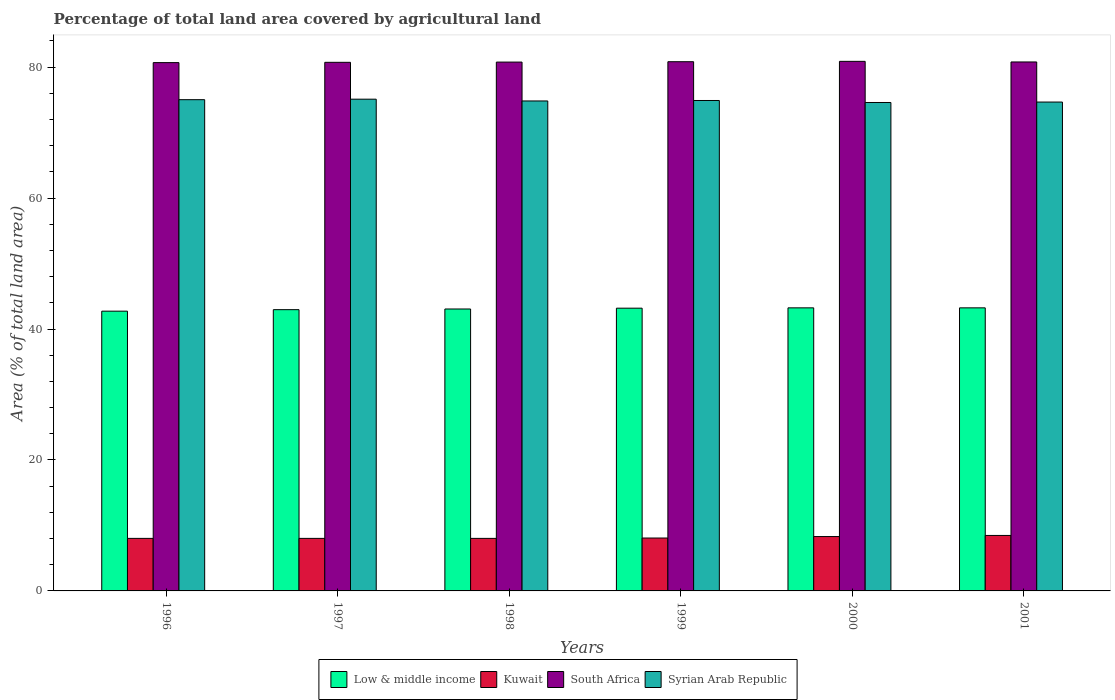How many different coloured bars are there?
Your answer should be very brief. 4. Are the number of bars on each tick of the X-axis equal?
Provide a short and direct response. Yes. How many bars are there on the 4th tick from the right?
Your answer should be very brief. 4. What is the label of the 6th group of bars from the left?
Your answer should be compact. 2001. In how many cases, is the number of bars for a given year not equal to the number of legend labels?
Ensure brevity in your answer.  0. What is the percentage of agricultural land in Syrian Arab Republic in 1997?
Make the answer very short. 75.11. Across all years, what is the maximum percentage of agricultural land in Low & middle income?
Give a very brief answer. 43.24. Across all years, what is the minimum percentage of agricultural land in South Africa?
Your response must be concise. 80.69. In which year was the percentage of agricultural land in Low & middle income minimum?
Your response must be concise. 1996. What is the total percentage of agricultural land in Syrian Arab Republic in the graph?
Offer a terse response. 449.17. What is the difference between the percentage of agricultural land in South Africa in 1996 and that in 1999?
Your answer should be very brief. -0.14. What is the difference between the percentage of agricultural land in South Africa in 1998 and the percentage of agricultural land in Low & middle income in 1997?
Ensure brevity in your answer.  37.81. What is the average percentage of agricultural land in Syrian Arab Republic per year?
Make the answer very short. 74.86. In the year 2000, what is the difference between the percentage of agricultural land in Kuwait and percentage of agricultural land in Syrian Arab Republic?
Keep it short and to the point. -66.3. What is the ratio of the percentage of agricultural land in South Africa in 1997 to that in 1999?
Your response must be concise. 1. Is the percentage of agricultural land in Syrian Arab Republic in 1997 less than that in 2001?
Your answer should be very brief. No. Is the difference between the percentage of agricultural land in Kuwait in 1999 and 2001 greater than the difference between the percentage of agricultural land in Syrian Arab Republic in 1999 and 2001?
Ensure brevity in your answer.  No. What is the difference between the highest and the second highest percentage of agricultural land in Syrian Arab Republic?
Keep it short and to the point. 0.08. What is the difference between the highest and the lowest percentage of agricultural land in Kuwait?
Give a very brief answer. 0.45. In how many years, is the percentage of agricultural land in South Africa greater than the average percentage of agricultural land in South Africa taken over all years?
Give a very brief answer. 3. Is the sum of the percentage of agricultural land in South Africa in 1998 and 2001 greater than the maximum percentage of agricultural land in Kuwait across all years?
Offer a very short reply. Yes. Is it the case that in every year, the sum of the percentage of agricultural land in Low & middle income and percentage of agricultural land in Syrian Arab Republic is greater than the sum of percentage of agricultural land in Kuwait and percentage of agricultural land in South Africa?
Provide a succinct answer. No. What does the 1st bar from the left in 1997 represents?
Your response must be concise. Low & middle income. What does the 3rd bar from the right in 1999 represents?
Your answer should be compact. Kuwait. Is it the case that in every year, the sum of the percentage of agricultural land in Kuwait and percentage of agricultural land in Syrian Arab Republic is greater than the percentage of agricultural land in South Africa?
Provide a succinct answer. Yes. Are all the bars in the graph horizontal?
Give a very brief answer. No. How many years are there in the graph?
Ensure brevity in your answer.  6. What is the difference between two consecutive major ticks on the Y-axis?
Provide a succinct answer. 20. Are the values on the major ticks of Y-axis written in scientific E-notation?
Offer a very short reply. No. Does the graph contain any zero values?
Provide a short and direct response. No. Does the graph contain grids?
Provide a succinct answer. No. Where does the legend appear in the graph?
Offer a terse response. Bottom center. What is the title of the graph?
Make the answer very short. Percentage of total land area covered by agricultural land. Does "Haiti" appear as one of the legend labels in the graph?
Make the answer very short. No. What is the label or title of the Y-axis?
Make the answer very short. Area (% of total land area). What is the Area (% of total land area) of Low & middle income in 1996?
Ensure brevity in your answer.  42.73. What is the Area (% of total land area) of Kuwait in 1996?
Ensure brevity in your answer.  8.02. What is the Area (% of total land area) of South Africa in 1996?
Provide a succinct answer. 80.69. What is the Area (% of total land area) of Syrian Arab Republic in 1996?
Keep it short and to the point. 75.04. What is the Area (% of total land area) in Low & middle income in 1997?
Your response must be concise. 42.96. What is the Area (% of total land area) in Kuwait in 1997?
Your answer should be very brief. 8.02. What is the Area (% of total land area) of South Africa in 1997?
Offer a very short reply. 80.74. What is the Area (% of total land area) in Syrian Arab Republic in 1997?
Your answer should be very brief. 75.11. What is the Area (% of total land area) in Low & middle income in 1998?
Your answer should be very brief. 43.06. What is the Area (% of total land area) of Kuwait in 1998?
Offer a very short reply. 8.02. What is the Area (% of total land area) in South Africa in 1998?
Ensure brevity in your answer.  80.78. What is the Area (% of total land area) of Syrian Arab Republic in 1998?
Provide a succinct answer. 74.84. What is the Area (% of total land area) of Low & middle income in 1999?
Keep it short and to the point. 43.19. What is the Area (% of total land area) of Kuwait in 1999?
Your answer should be very brief. 8.08. What is the Area (% of total land area) in South Africa in 1999?
Provide a short and direct response. 80.83. What is the Area (% of total land area) in Syrian Arab Republic in 1999?
Your response must be concise. 74.91. What is the Area (% of total land area) in Low & middle income in 2000?
Your answer should be very brief. 43.24. What is the Area (% of total land area) in Kuwait in 2000?
Your answer should be compact. 8.31. What is the Area (% of total land area) in South Africa in 2000?
Give a very brief answer. 80.89. What is the Area (% of total land area) of Syrian Arab Republic in 2000?
Provide a short and direct response. 74.61. What is the Area (% of total land area) of Low & middle income in 2001?
Provide a short and direct response. 43.24. What is the Area (% of total land area) of Kuwait in 2001?
Offer a terse response. 8.47. What is the Area (% of total land area) in South Africa in 2001?
Keep it short and to the point. 80.8. What is the Area (% of total land area) of Syrian Arab Republic in 2001?
Make the answer very short. 74.67. Across all years, what is the maximum Area (% of total land area) in Low & middle income?
Offer a terse response. 43.24. Across all years, what is the maximum Area (% of total land area) of Kuwait?
Provide a short and direct response. 8.47. Across all years, what is the maximum Area (% of total land area) of South Africa?
Give a very brief answer. 80.89. Across all years, what is the maximum Area (% of total land area) of Syrian Arab Republic?
Offer a very short reply. 75.11. Across all years, what is the minimum Area (% of total land area) in Low & middle income?
Offer a terse response. 42.73. Across all years, what is the minimum Area (% of total land area) in Kuwait?
Make the answer very short. 8.02. Across all years, what is the minimum Area (% of total land area) of South Africa?
Make the answer very short. 80.69. Across all years, what is the minimum Area (% of total land area) in Syrian Arab Republic?
Your response must be concise. 74.61. What is the total Area (% of total land area) in Low & middle income in the graph?
Your response must be concise. 258.42. What is the total Area (% of total land area) of Kuwait in the graph?
Offer a terse response. 48.93. What is the total Area (% of total land area) in South Africa in the graph?
Provide a short and direct response. 484.73. What is the total Area (% of total land area) in Syrian Arab Republic in the graph?
Your answer should be compact. 449.17. What is the difference between the Area (% of total land area) of Low & middle income in 1996 and that in 1997?
Ensure brevity in your answer.  -0.23. What is the difference between the Area (% of total land area) of South Africa in 1996 and that in 1997?
Offer a terse response. -0.05. What is the difference between the Area (% of total land area) of Syrian Arab Republic in 1996 and that in 1997?
Ensure brevity in your answer.  -0.08. What is the difference between the Area (% of total land area) in Low & middle income in 1996 and that in 1998?
Offer a very short reply. -0.33. What is the difference between the Area (% of total land area) of South Africa in 1996 and that in 1998?
Provide a succinct answer. -0.08. What is the difference between the Area (% of total land area) of Syrian Arab Republic in 1996 and that in 1998?
Your answer should be very brief. 0.2. What is the difference between the Area (% of total land area) of Low & middle income in 1996 and that in 1999?
Your answer should be very brief. -0.45. What is the difference between the Area (% of total land area) in Kuwait in 1996 and that in 1999?
Give a very brief answer. -0.06. What is the difference between the Area (% of total land area) in South Africa in 1996 and that in 1999?
Keep it short and to the point. -0.14. What is the difference between the Area (% of total land area) in Syrian Arab Republic in 1996 and that in 1999?
Your answer should be compact. 0.13. What is the difference between the Area (% of total land area) of Low & middle income in 1996 and that in 2000?
Make the answer very short. -0.51. What is the difference between the Area (% of total land area) in Kuwait in 1996 and that in 2000?
Provide a short and direct response. -0.28. What is the difference between the Area (% of total land area) in South Africa in 1996 and that in 2000?
Offer a very short reply. -0.19. What is the difference between the Area (% of total land area) in Syrian Arab Republic in 1996 and that in 2000?
Provide a succinct answer. 0.43. What is the difference between the Area (% of total land area) of Low & middle income in 1996 and that in 2001?
Make the answer very short. -0.51. What is the difference between the Area (% of total land area) of Kuwait in 1996 and that in 2001?
Give a very brief answer. -0.45. What is the difference between the Area (% of total land area) of South Africa in 1996 and that in 2001?
Make the answer very short. -0.1. What is the difference between the Area (% of total land area) of Syrian Arab Republic in 1996 and that in 2001?
Provide a succinct answer. 0.36. What is the difference between the Area (% of total land area) in Low & middle income in 1997 and that in 1998?
Give a very brief answer. -0.1. What is the difference between the Area (% of total land area) of South Africa in 1997 and that in 1998?
Ensure brevity in your answer.  -0.04. What is the difference between the Area (% of total land area) of Syrian Arab Republic in 1997 and that in 1998?
Your answer should be very brief. 0.27. What is the difference between the Area (% of total land area) in Low & middle income in 1997 and that in 1999?
Your answer should be very brief. -0.22. What is the difference between the Area (% of total land area) of Kuwait in 1997 and that in 1999?
Your response must be concise. -0.06. What is the difference between the Area (% of total land area) in South Africa in 1997 and that in 1999?
Provide a short and direct response. -0.09. What is the difference between the Area (% of total land area) in Syrian Arab Republic in 1997 and that in 1999?
Provide a succinct answer. 0.2. What is the difference between the Area (% of total land area) of Low & middle income in 1997 and that in 2000?
Offer a very short reply. -0.28. What is the difference between the Area (% of total land area) of Kuwait in 1997 and that in 2000?
Provide a succinct answer. -0.28. What is the difference between the Area (% of total land area) in South Africa in 1997 and that in 2000?
Your answer should be compact. -0.15. What is the difference between the Area (% of total land area) of Syrian Arab Republic in 1997 and that in 2000?
Your answer should be very brief. 0.51. What is the difference between the Area (% of total land area) of Low & middle income in 1997 and that in 2001?
Give a very brief answer. -0.28. What is the difference between the Area (% of total land area) of Kuwait in 1997 and that in 2001?
Make the answer very short. -0.45. What is the difference between the Area (% of total land area) of South Africa in 1997 and that in 2001?
Keep it short and to the point. -0.06. What is the difference between the Area (% of total land area) in Syrian Arab Republic in 1997 and that in 2001?
Your response must be concise. 0.44. What is the difference between the Area (% of total land area) of Low & middle income in 1998 and that in 1999?
Your answer should be compact. -0.12. What is the difference between the Area (% of total land area) of Kuwait in 1998 and that in 1999?
Make the answer very short. -0.06. What is the difference between the Area (% of total land area) of South Africa in 1998 and that in 1999?
Your response must be concise. -0.06. What is the difference between the Area (% of total land area) in Syrian Arab Republic in 1998 and that in 1999?
Make the answer very short. -0.07. What is the difference between the Area (% of total land area) of Low & middle income in 1998 and that in 2000?
Provide a succinct answer. -0.18. What is the difference between the Area (% of total land area) of Kuwait in 1998 and that in 2000?
Your answer should be compact. -0.28. What is the difference between the Area (% of total land area) of South Africa in 1998 and that in 2000?
Give a very brief answer. -0.11. What is the difference between the Area (% of total land area) in Syrian Arab Republic in 1998 and that in 2000?
Keep it short and to the point. 0.23. What is the difference between the Area (% of total land area) of Low & middle income in 1998 and that in 2001?
Your answer should be compact. -0.17. What is the difference between the Area (% of total land area) of Kuwait in 1998 and that in 2001?
Make the answer very short. -0.45. What is the difference between the Area (% of total land area) of South Africa in 1998 and that in 2001?
Keep it short and to the point. -0.02. What is the difference between the Area (% of total land area) of Syrian Arab Republic in 1998 and that in 2001?
Offer a very short reply. 0.17. What is the difference between the Area (% of total land area) in Low & middle income in 1999 and that in 2000?
Give a very brief answer. -0.05. What is the difference between the Area (% of total land area) of Kuwait in 1999 and that in 2000?
Make the answer very short. -0.22. What is the difference between the Area (% of total land area) of South Africa in 1999 and that in 2000?
Your answer should be very brief. -0.06. What is the difference between the Area (% of total land area) of Syrian Arab Republic in 1999 and that in 2000?
Ensure brevity in your answer.  0.3. What is the difference between the Area (% of total land area) of Low & middle income in 1999 and that in 2001?
Your response must be concise. -0.05. What is the difference between the Area (% of total land area) of Kuwait in 1999 and that in 2001?
Offer a very short reply. -0.39. What is the difference between the Area (% of total land area) of South Africa in 1999 and that in 2001?
Offer a terse response. 0.04. What is the difference between the Area (% of total land area) in Syrian Arab Republic in 1999 and that in 2001?
Your answer should be very brief. 0.24. What is the difference between the Area (% of total land area) of Low & middle income in 2000 and that in 2001?
Make the answer very short. 0. What is the difference between the Area (% of total land area) of Kuwait in 2000 and that in 2001?
Offer a very short reply. -0.17. What is the difference between the Area (% of total land area) in South Africa in 2000 and that in 2001?
Offer a terse response. 0.09. What is the difference between the Area (% of total land area) of Syrian Arab Republic in 2000 and that in 2001?
Offer a very short reply. -0.07. What is the difference between the Area (% of total land area) of Low & middle income in 1996 and the Area (% of total land area) of Kuwait in 1997?
Your response must be concise. 34.71. What is the difference between the Area (% of total land area) of Low & middle income in 1996 and the Area (% of total land area) of South Africa in 1997?
Provide a short and direct response. -38.01. What is the difference between the Area (% of total land area) in Low & middle income in 1996 and the Area (% of total land area) in Syrian Arab Republic in 1997?
Your response must be concise. -32.38. What is the difference between the Area (% of total land area) in Kuwait in 1996 and the Area (% of total land area) in South Africa in 1997?
Make the answer very short. -72.72. What is the difference between the Area (% of total land area) of Kuwait in 1996 and the Area (% of total land area) of Syrian Arab Republic in 1997?
Your answer should be compact. -67.09. What is the difference between the Area (% of total land area) of South Africa in 1996 and the Area (% of total land area) of Syrian Arab Republic in 1997?
Provide a succinct answer. 5.58. What is the difference between the Area (% of total land area) in Low & middle income in 1996 and the Area (% of total land area) in Kuwait in 1998?
Your response must be concise. 34.71. What is the difference between the Area (% of total land area) of Low & middle income in 1996 and the Area (% of total land area) of South Africa in 1998?
Your response must be concise. -38.04. What is the difference between the Area (% of total land area) in Low & middle income in 1996 and the Area (% of total land area) in Syrian Arab Republic in 1998?
Keep it short and to the point. -32.11. What is the difference between the Area (% of total land area) in Kuwait in 1996 and the Area (% of total land area) in South Africa in 1998?
Your answer should be very brief. -72.75. What is the difference between the Area (% of total land area) of Kuwait in 1996 and the Area (% of total land area) of Syrian Arab Republic in 1998?
Your answer should be compact. -66.81. What is the difference between the Area (% of total land area) in South Africa in 1996 and the Area (% of total land area) in Syrian Arab Republic in 1998?
Offer a very short reply. 5.86. What is the difference between the Area (% of total land area) in Low & middle income in 1996 and the Area (% of total land area) in Kuwait in 1999?
Provide a succinct answer. 34.65. What is the difference between the Area (% of total land area) in Low & middle income in 1996 and the Area (% of total land area) in South Africa in 1999?
Your answer should be very brief. -38.1. What is the difference between the Area (% of total land area) in Low & middle income in 1996 and the Area (% of total land area) in Syrian Arab Republic in 1999?
Provide a succinct answer. -32.18. What is the difference between the Area (% of total land area) in Kuwait in 1996 and the Area (% of total land area) in South Africa in 1999?
Provide a succinct answer. -72.81. What is the difference between the Area (% of total land area) in Kuwait in 1996 and the Area (% of total land area) in Syrian Arab Republic in 1999?
Your answer should be very brief. -66.89. What is the difference between the Area (% of total land area) in South Africa in 1996 and the Area (% of total land area) in Syrian Arab Republic in 1999?
Provide a short and direct response. 5.78. What is the difference between the Area (% of total land area) in Low & middle income in 1996 and the Area (% of total land area) in Kuwait in 2000?
Your response must be concise. 34.43. What is the difference between the Area (% of total land area) of Low & middle income in 1996 and the Area (% of total land area) of South Africa in 2000?
Offer a very short reply. -38.16. What is the difference between the Area (% of total land area) of Low & middle income in 1996 and the Area (% of total land area) of Syrian Arab Republic in 2000?
Make the answer very short. -31.87. What is the difference between the Area (% of total land area) of Kuwait in 1996 and the Area (% of total land area) of South Africa in 2000?
Make the answer very short. -72.86. What is the difference between the Area (% of total land area) of Kuwait in 1996 and the Area (% of total land area) of Syrian Arab Republic in 2000?
Offer a terse response. -66.58. What is the difference between the Area (% of total land area) in South Africa in 1996 and the Area (% of total land area) in Syrian Arab Republic in 2000?
Provide a short and direct response. 6.09. What is the difference between the Area (% of total land area) in Low & middle income in 1996 and the Area (% of total land area) in Kuwait in 2001?
Offer a very short reply. 34.26. What is the difference between the Area (% of total land area) in Low & middle income in 1996 and the Area (% of total land area) in South Africa in 2001?
Make the answer very short. -38.06. What is the difference between the Area (% of total land area) of Low & middle income in 1996 and the Area (% of total land area) of Syrian Arab Republic in 2001?
Provide a short and direct response. -31.94. What is the difference between the Area (% of total land area) of Kuwait in 1996 and the Area (% of total land area) of South Africa in 2001?
Give a very brief answer. -72.77. What is the difference between the Area (% of total land area) of Kuwait in 1996 and the Area (% of total land area) of Syrian Arab Republic in 2001?
Offer a very short reply. -66.65. What is the difference between the Area (% of total land area) of South Africa in 1996 and the Area (% of total land area) of Syrian Arab Republic in 2001?
Provide a succinct answer. 6.02. What is the difference between the Area (% of total land area) in Low & middle income in 1997 and the Area (% of total land area) in Kuwait in 1998?
Keep it short and to the point. 34.94. What is the difference between the Area (% of total land area) in Low & middle income in 1997 and the Area (% of total land area) in South Africa in 1998?
Ensure brevity in your answer.  -37.81. What is the difference between the Area (% of total land area) in Low & middle income in 1997 and the Area (% of total land area) in Syrian Arab Republic in 1998?
Provide a short and direct response. -31.88. What is the difference between the Area (% of total land area) in Kuwait in 1997 and the Area (% of total land area) in South Africa in 1998?
Provide a short and direct response. -72.75. What is the difference between the Area (% of total land area) of Kuwait in 1997 and the Area (% of total land area) of Syrian Arab Republic in 1998?
Provide a succinct answer. -66.81. What is the difference between the Area (% of total land area) of South Africa in 1997 and the Area (% of total land area) of Syrian Arab Republic in 1998?
Provide a short and direct response. 5.9. What is the difference between the Area (% of total land area) of Low & middle income in 1997 and the Area (% of total land area) of Kuwait in 1999?
Ensure brevity in your answer.  34.88. What is the difference between the Area (% of total land area) in Low & middle income in 1997 and the Area (% of total land area) in South Africa in 1999?
Your answer should be very brief. -37.87. What is the difference between the Area (% of total land area) in Low & middle income in 1997 and the Area (% of total land area) in Syrian Arab Republic in 1999?
Your answer should be compact. -31.95. What is the difference between the Area (% of total land area) of Kuwait in 1997 and the Area (% of total land area) of South Africa in 1999?
Make the answer very short. -72.81. What is the difference between the Area (% of total land area) of Kuwait in 1997 and the Area (% of total land area) of Syrian Arab Republic in 1999?
Your response must be concise. -66.89. What is the difference between the Area (% of total land area) of South Africa in 1997 and the Area (% of total land area) of Syrian Arab Republic in 1999?
Keep it short and to the point. 5.83. What is the difference between the Area (% of total land area) in Low & middle income in 1997 and the Area (% of total land area) in Kuwait in 2000?
Your response must be concise. 34.66. What is the difference between the Area (% of total land area) in Low & middle income in 1997 and the Area (% of total land area) in South Africa in 2000?
Give a very brief answer. -37.93. What is the difference between the Area (% of total land area) of Low & middle income in 1997 and the Area (% of total land area) of Syrian Arab Republic in 2000?
Offer a very short reply. -31.64. What is the difference between the Area (% of total land area) of Kuwait in 1997 and the Area (% of total land area) of South Africa in 2000?
Offer a terse response. -72.86. What is the difference between the Area (% of total land area) in Kuwait in 1997 and the Area (% of total land area) in Syrian Arab Republic in 2000?
Your answer should be very brief. -66.58. What is the difference between the Area (% of total land area) in South Africa in 1997 and the Area (% of total land area) in Syrian Arab Republic in 2000?
Keep it short and to the point. 6.13. What is the difference between the Area (% of total land area) in Low & middle income in 1997 and the Area (% of total land area) in Kuwait in 2001?
Give a very brief answer. 34.49. What is the difference between the Area (% of total land area) in Low & middle income in 1997 and the Area (% of total land area) in South Africa in 2001?
Offer a terse response. -37.83. What is the difference between the Area (% of total land area) of Low & middle income in 1997 and the Area (% of total land area) of Syrian Arab Republic in 2001?
Provide a succinct answer. -31.71. What is the difference between the Area (% of total land area) of Kuwait in 1997 and the Area (% of total land area) of South Africa in 2001?
Your answer should be compact. -72.77. What is the difference between the Area (% of total land area) in Kuwait in 1997 and the Area (% of total land area) in Syrian Arab Republic in 2001?
Your answer should be very brief. -66.65. What is the difference between the Area (% of total land area) in South Africa in 1997 and the Area (% of total land area) in Syrian Arab Republic in 2001?
Your response must be concise. 6.07. What is the difference between the Area (% of total land area) of Low & middle income in 1998 and the Area (% of total land area) of Kuwait in 1999?
Your answer should be compact. 34.98. What is the difference between the Area (% of total land area) in Low & middle income in 1998 and the Area (% of total land area) in South Africa in 1999?
Provide a short and direct response. -37.77. What is the difference between the Area (% of total land area) of Low & middle income in 1998 and the Area (% of total land area) of Syrian Arab Republic in 1999?
Your answer should be compact. -31.85. What is the difference between the Area (% of total land area) in Kuwait in 1998 and the Area (% of total land area) in South Africa in 1999?
Make the answer very short. -72.81. What is the difference between the Area (% of total land area) in Kuwait in 1998 and the Area (% of total land area) in Syrian Arab Republic in 1999?
Your response must be concise. -66.89. What is the difference between the Area (% of total land area) of South Africa in 1998 and the Area (% of total land area) of Syrian Arab Republic in 1999?
Keep it short and to the point. 5.87. What is the difference between the Area (% of total land area) of Low & middle income in 1998 and the Area (% of total land area) of Kuwait in 2000?
Your answer should be compact. 34.76. What is the difference between the Area (% of total land area) in Low & middle income in 1998 and the Area (% of total land area) in South Africa in 2000?
Your answer should be compact. -37.83. What is the difference between the Area (% of total land area) in Low & middle income in 1998 and the Area (% of total land area) in Syrian Arab Republic in 2000?
Ensure brevity in your answer.  -31.54. What is the difference between the Area (% of total land area) in Kuwait in 1998 and the Area (% of total land area) in South Africa in 2000?
Ensure brevity in your answer.  -72.86. What is the difference between the Area (% of total land area) in Kuwait in 1998 and the Area (% of total land area) in Syrian Arab Republic in 2000?
Offer a terse response. -66.58. What is the difference between the Area (% of total land area) in South Africa in 1998 and the Area (% of total land area) in Syrian Arab Republic in 2000?
Provide a succinct answer. 6.17. What is the difference between the Area (% of total land area) in Low & middle income in 1998 and the Area (% of total land area) in Kuwait in 2001?
Provide a succinct answer. 34.59. What is the difference between the Area (% of total land area) in Low & middle income in 1998 and the Area (% of total land area) in South Africa in 2001?
Give a very brief answer. -37.73. What is the difference between the Area (% of total land area) of Low & middle income in 1998 and the Area (% of total land area) of Syrian Arab Republic in 2001?
Offer a very short reply. -31.61. What is the difference between the Area (% of total land area) of Kuwait in 1998 and the Area (% of total land area) of South Africa in 2001?
Ensure brevity in your answer.  -72.77. What is the difference between the Area (% of total land area) of Kuwait in 1998 and the Area (% of total land area) of Syrian Arab Republic in 2001?
Make the answer very short. -66.65. What is the difference between the Area (% of total land area) in South Africa in 1998 and the Area (% of total land area) in Syrian Arab Republic in 2001?
Your response must be concise. 6.1. What is the difference between the Area (% of total land area) in Low & middle income in 1999 and the Area (% of total land area) in Kuwait in 2000?
Offer a very short reply. 34.88. What is the difference between the Area (% of total land area) of Low & middle income in 1999 and the Area (% of total land area) of South Africa in 2000?
Make the answer very short. -37.7. What is the difference between the Area (% of total land area) of Low & middle income in 1999 and the Area (% of total land area) of Syrian Arab Republic in 2000?
Offer a very short reply. -31.42. What is the difference between the Area (% of total land area) in Kuwait in 1999 and the Area (% of total land area) in South Africa in 2000?
Provide a succinct answer. -72.81. What is the difference between the Area (% of total land area) in Kuwait in 1999 and the Area (% of total land area) in Syrian Arab Republic in 2000?
Your answer should be compact. -66.52. What is the difference between the Area (% of total land area) of South Africa in 1999 and the Area (% of total land area) of Syrian Arab Republic in 2000?
Ensure brevity in your answer.  6.23. What is the difference between the Area (% of total land area) of Low & middle income in 1999 and the Area (% of total land area) of Kuwait in 2001?
Make the answer very short. 34.71. What is the difference between the Area (% of total land area) of Low & middle income in 1999 and the Area (% of total land area) of South Africa in 2001?
Make the answer very short. -37.61. What is the difference between the Area (% of total land area) of Low & middle income in 1999 and the Area (% of total land area) of Syrian Arab Republic in 2001?
Your response must be concise. -31.48. What is the difference between the Area (% of total land area) in Kuwait in 1999 and the Area (% of total land area) in South Africa in 2001?
Your answer should be very brief. -72.72. What is the difference between the Area (% of total land area) in Kuwait in 1999 and the Area (% of total land area) in Syrian Arab Republic in 2001?
Your response must be concise. -66.59. What is the difference between the Area (% of total land area) in South Africa in 1999 and the Area (% of total land area) in Syrian Arab Republic in 2001?
Ensure brevity in your answer.  6.16. What is the difference between the Area (% of total land area) in Low & middle income in 2000 and the Area (% of total land area) in Kuwait in 2001?
Provide a short and direct response. 34.76. What is the difference between the Area (% of total land area) in Low & middle income in 2000 and the Area (% of total land area) in South Africa in 2001?
Your answer should be compact. -37.56. What is the difference between the Area (% of total land area) in Low & middle income in 2000 and the Area (% of total land area) in Syrian Arab Republic in 2001?
Your answer should be very brief. -31.43. What is the difference between the Area (% of total land area) of Kuwait in 2000 and the Area (% of total land area) of South Africa in 2001?
Your answer should be very brief. -72.49. What is the difference between the Area (% of total land area) of Kuwait in 2000 and the Area (% of total land area) of Syrian Arab Republic in 2001?
Your answer should be compact. -66.37. What is the difference between the Area (% of total land area) of South Africa in 2000 and the Area (% of total land area) of Syrian Arab Republic in 2001?
Your answer should be very brief. 6.22. What is the average Area (% of total land area) in Low & middle income per year?
Your answer should be compact. 43.07. What is the average Area (% of total land area) of Kuwait per year?
Your answer should be compact. 8.16. What is the average Area (% of total land area) of South Africa per year?
Your answer should be compact. 80.79. What is the average Area (% of total land area) in Syrian Arab Republic per year?
Offer a very short reply. 74.86. In the year 1996, what is the difference between the Area (% of total land area) of Low & middle income and Area (% of total land area) of Kuwait?
Make the answer very short. 34.71. In the year 1996, what is the difference between the Area (% of total land area) in Low & middle income and Area (% of total land area) in South Africa?
Provide a succinct answer. -37.96. In the year 1996, what is the difference between the Area (% of total land area) of Low & middle income and Area (% of total land area) of Syrian Arab Republic?
Ensure brevity in your answer.  -32.3. In the year 1996, what is the difference between the Area (% of total land area) in Kuwait and Area (% of total land area) in South Africa?
Make the answer very short. -72.67. In the year 1996, what is the difference between the Area (% of total land area) of Kuwait and Area (% of total land area) of Syrian Arab Republic?
Ensure brevity in your answer.  -67.01. In the year 1996, what is the difference between the Area (% of total land area) in South Africa and Area (% of total land area) in Syrian Arab Republic?
Give a very brief answer. 5.66. In the year 1997, what is the difference between the Area (% of total land area) of Low & middle income and Area (% of total land area) of Kuwait?
Your answer should be very brief. 34.94. In the year 1997, what is the difference between the Area (% of total land area) in Low & middle income and Area (% of total land area) in South Africa?
Make the answer very short. -37.78. In the year 1997, what is the difference between the Area (% of total land area) in Low & middle income and Area (% of total land area) in Syrian Arab Republic?
Make the answer very short. -32.15. In the year 1997, what is the difference between the Area (% of total land area) in Kuwait and Area (% of total land area) in South Africa?
Keep it short and to the point. -72.72. In the year 1997, what is the difference between the Area (% of total land area) of Kuwait and Area (% of total land area) of Syrian Arab Republic?
Your response must be concise. -67.09. In the year 1997, what is the difference between the Area (% of total land area) in South Africa and Area (% of total land area) in Syrian Arab Republic?
Your answer should be very brief. 5.63. In the year 1998, what is the difference between the Area (% of total land area) in Low & middle income and Area (% of total land area) in Kuwait?
Your answer should be very brief. 35.04. In the year 1998, what is the difference between the Area (% of total land area) of Low & middle income and Area (% of total land area) of South Africa?
Keep it short and to the point. -37.71. In the year 1998, what is the difference between the Area (% of total land area) in Low & middle income and Area (% of total land area) in Syrian Arab Republic?
Your response must be concise. -31.78. In the year 1998, what is the difference between the Area (% of total land area) of Kuwait and Area (% of total land area) of South Africa?
Give a very brief answer. -72.75. In the year 1998, what is the difference between the Area (% of total land area) of Kuwait and Area (% of total land area) of Syrian Arab Republic?
Keep it short and to the point. -66.81. In the year 1998, what is the difference between the Area (% of total land area) of South Africa and Area (% of total land area) of Syrian Arab Republic?
Keep it short and to the point. 5.94. In the year 1999, what is the difference between the Area (% of total land area) of Low & middle income and Area (% of total land area) of Kuwait?
Keep it short and to the point. 35.11. In the year 1999, what is the difference between the Area (% of total land area) in Low & middle income and Area (% of total land area) in South Africa?
Offer a terse response. -37.65. In the year 1999, what is the difference between the Area (% of total land area) of Low & middle income and Area (% of total land area) of Syrian Arab Republic?
Offer a terse response. -31.72. In the year 1999, what is the difference between the Area (% of total land area) of Kuwait and Area (% of total land area) of South Africa?
Keep it short and to the point. -72.75. In the year 1999, what is the difference between the Area (% of total land area) in Kuwait and Area (% of total land area) in Syrian Arab Republic?
Keep it short and to the point. -66.83. In the year 1999, what is the difference between the Area (% of total land area) in South Africa and Area (% of total land area) in Syrian Arab Republic?
Make the answer very short. 5.92. In the year 2000, what is the difference between the Area (% of total land area) in Low & middle income and Area (% of total land area) in Kuwait?
Offer a terse response. 34.93. In the year 2000, what is the difference between the Area (% of total land area) of Low & middle income and Area (% of total land area) of South Africa?
Give a very brief answer. -37.65. In the year 2000, what is the difference between the Area (% of total land area) of Low & middle income and Area (% of total land area) of Syrian Arab Republic?
Ensure brevity in your answer.  -31.37. In the year 2000, what is the difference between the Area (% of total land area) in Kuwait and Area (% of total land area) in South Africa?
Provide a succinct answer. -72.58. In the year 2000, what is the difference between the Area (% of total land area) of Kuwait and Area (% of total land area) of Syrian Arab Republic?
Provide a succinct answer. -66.3. In the year 2000, what is the difference between the Area (% of total land area) in South Africa and Area (% of total land area) in Syrian Arab Republic?
Give a very brief answer. 6.28. In the year 2001, what is the difference between the Area (% of total land area) of Low & middle income and Area (% of total land area) of Kuwait?
Provide a short and direct response. 34.76. In the year 2001, what is the difference between the Area (% of total land area) of Low & middle income and Area (% of total land area) of South Africa?
Provide a succinct answer. -37.56. In the year 2001, what is the difference between the Area (% of total land area) in Low & middle income and Area (% of total land area) in Syrian Arab Republic?
Ensure brevity in your answer.  -31.43. In the year 2001, what is the difference between the Area (% of total land area) of Kuwait and Area (% of total land area) of South Africa?
Your answer should be very brief. -72.32. In the year 2001, what is the difference between the Area (% of total land area) in Kuwait and Area (% of total land area) in Syrian Arab Republic?
Make the answer very short. -66.2. In the year 2001, what is the difference between the Area (% of total land area) of South Africa and Area (% of total land area) of Syrian Arab Republic?
Your response must be concise. 6.13. What is the ratio of the Area (% of total land area) of Low & middle income in 1996 to that in 1997?
Your response must be concise. 0.99. What is the ratio of the Area (% of total land area) of Kuwait in 1996 to that in 1997?
Ensure brevity in your answer.  1. What is the ratio of the Area (% of total land area) in South Africa in 1996 to that in 1997?
Your answer should be very brief. 1. What is the ratio of the Area (% of total land area) of South Africa in 1996 to that in 1998?
Keep it short and to the point. 1. What is the ratio of the Area (% of total land area) in South Africa in 1996 to that in 1999?
Provide a short and direct response. 1. What is the ratio of the Area (% of total land area) of Syrian Arab Republic in 1996 to that in 1999?
Provide a succinct answer. 1. What is the ratio of the Area (% of total land area) in Low & middle income in 1996 to that in 2000?
Ensure brevity in your answer.  0.99. What is the ratio of the Area (% of total land area) of Kuwait in 1996 to that in 2000?
Provide a succinct answer. 0.97. What is the ratio of the Area (% of total land area) in Syrian Arab Republic in 1996 to that in 2000?
Provide a succinct answer. 1.01. What is the ratio of the Area (% of total land area) in Low & middle income in 1996 to that in 2001?
Offer a terse response. 0.99. What is the ratio of the Area (% of total land area) of Kuwait in 1996 to that in 2001?
Offer a terse response. 0.95. What is the ratio of the Area (% of total land area) of Syrian Arab Republic in 1996 to that in 2001?
Provide a succinct answer. 1. What is the ratio of the Area (% of total land area) of Low & middle income in 1997 to that in 1998?
Ensure brevity in your answer.  1. What is the ratio of the Area (% of total land area) in South Africa in 1997 to that in 1998?
Your answer should be very brief. 1. What is the ratio of the Area (% of total land area) in Kuwait in 1997 to that in 1999?
Your response must be concise. 0.99. What is the ratio of the Area (% of total land area) in Syrian Arab Republic in 1997 to that in 1999?
Offer a terse response. 1. What is the ratio of the Area (% of total land area) in Kuwait in 1997 to that in 2000?
Make the answer very short. 0.97. What is the ratio of the Area (% of total land area) of South Africa in 1997 to that in 2000?
Your response must be concise. 1. What is the ratio of the Area (% of total land area) in Syrian Arab Republic in 1997 to that in 2000?
Your answer should be very brief. 1.01. What is the ratio of the Area (% of total land area) of Kuwait in 1997 to that in 2001?
Give a very brief answer. 0.95. What is the ratio of the Area (% of total land area) of Syrian Arab Republic in 1997 to that in 2001?
Keep it short and to the point. 1.01. What is the ratio of the Area (% of total land area) in Kuwait in 1998 to that in 1999?
Make the answer very short. 0.99. What is the ratio of the Area (% of total land area) in South Africa in 1998 to that in 1999?
Offer a very short reply. 1. What is the ratio of the Area (% of total land area) in Syrian Arab Republic in 1998 to that in 1999?
Make the answer very short. 1. What is the ratio of the Area (% of total land area) of Low & middle income in 1998 to that in 2000?
Your response must be concise. 1. What is the ratio of the Area (% of total land area) of Kuwait in 1998 to that in 2000?
Make the answer very short. 0.97. What is the ratio of the Area (% of total land area) in Syrian Arab Republic in 1998 to that in 2000?
Offer a terse response. 1. What is the ratio of the Area (% of total land area) in Low & middle income in 1998 to that in 2001?
Give a very brief answer. 1. What is the ratio of the Area (% of total land area) in Kuwait in 1998 to that in 2001?
Offer a terse response. 0.95. What is the ratio of the Area (% of total land area) in Syrian Arab Republic in 1998 to that in 2001?
Provide a short and direct response. 1. What is the ratio of the Area (% of total land area) in Low & middle income in 1999 to that in 2000?
Ensure brevity in your answer.  1. What is the ratio of the Area (% of total land area) in Kuwait in 1999 to that in 2000?
Your answer should be very brief. 0.97. What is the ratio of the Area (% of total land area) in South Africa in 1999 to that in 2000?
Offer a terse response. 1. What is the ratio of the Area (% of total land area) in Syrian Arab Republic in 1999 to that in 2000?
Offer a very short reply. 1. What is the ratio of the Area (% of total land area) in Low & middle income in 1999 to that in 2001?
Provide a succinct answer. 1. What is the ratio of the Area (% of total land area) of Kuwait in 1999 to that in 2001?
Give a very brief answer. 0.95. What is the ratio of the Area (% of total land area) in Kuwait in 2000 to that in 2001?
Your answer should be very brief. 0.98. What is the ratio of the Area (% of total land area) in South Africa in 2000 to that in 2001?
Ensure brevity in your answer.  1. What is the ratio of the Area (% of total land area) of Syrian Arab Republic in 2000 to that in 2001?
Your response must be concise. 1. What is the difference between the highest and the second highest Area (% of total land area) in Low & middle income?
Provide a succinct answer. 0. What is the difference between the highest and the second highest Area (% of total land area) in Kuwait?
Your answer should be compact. 0.17. What is the difference between the highest and the second highest Area (% of total land area) in South Africa?
Keep it short and to the point. 0.06. What is the difference between the highest and the second highest Area (% of total land area) in Syrian Arab Republic?
Your answer should be compact. 0.08. What is the difference between the highest and the lowest Area (% of total land area) in Low & middle income?
Provide a succinct answer. 0.51. What is the difference between the highest and the lowest Area (% of total land area) of Kuwait?
Offer a terse response. 0.45. What is the difference between the highest and the lowest Area (% of total land area) in South Africa?
Offer a terse response. 0.19. What is the difference between the highest and the lowest Area (% of total land area) in Syrian Arab Republic?
Your response must be concise. 0.51. 